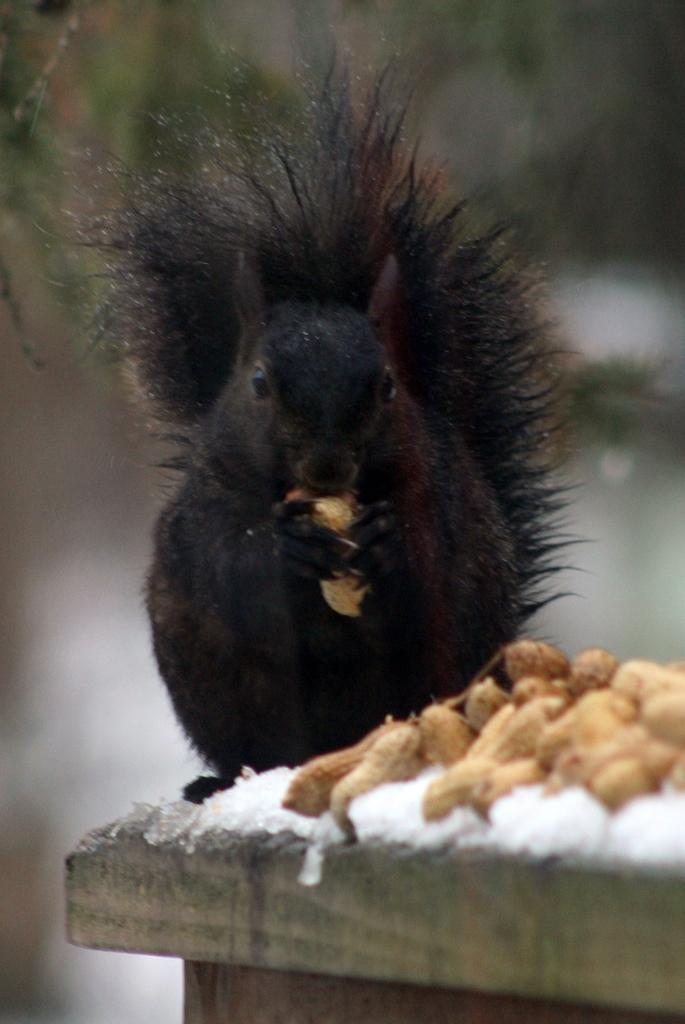What type of animal is in the image? There is a black squirrel in the image. What is the squirrel standing on? The squirrel is standing on a wooden surface. What food items are visible in the image? There are peanuts and ice in the image. How would you describe the background of the image? The background of the image is blurred. What day of the week is the chicken celebrating in the image? There is no chicken present in the image, so it is not possible to determine what day of the week it might be celebrating. 